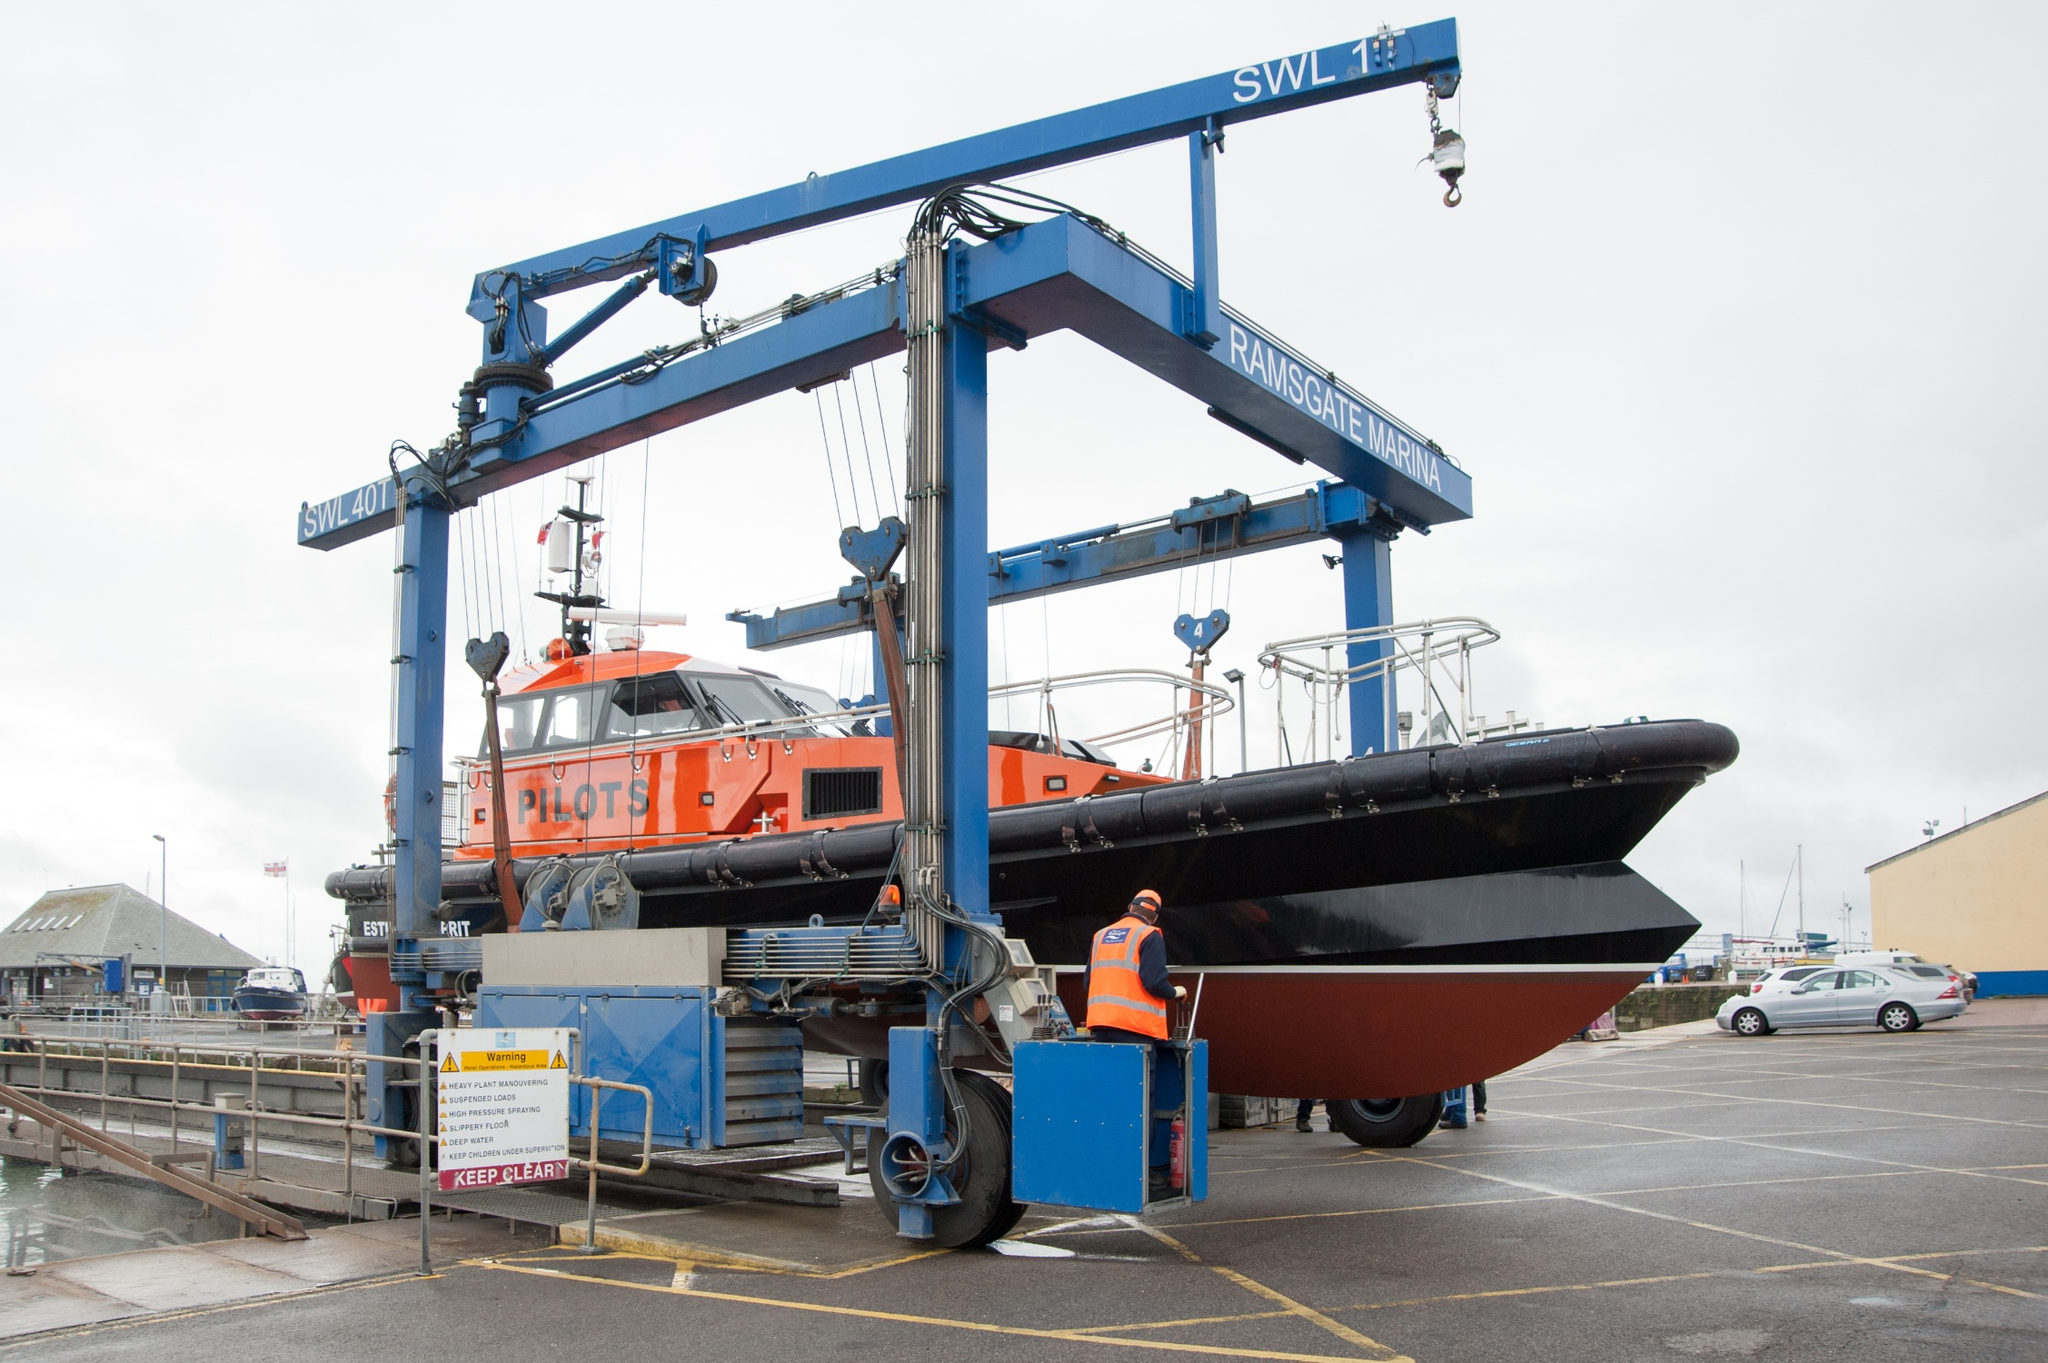What does the sign 'SWL 7t' on the crane signify? The 'SWL 7t' sign on the crane stands for 'Safe Working Load 7 tons.' This is a crucial safety measure, indicating the maximum load the crane can safely lift. Understanding and adhering to the SWL is vital for ensuring the safety of operations within industrial and maritime environments like this, preventing overloading and potential accidents during lifting operations. 